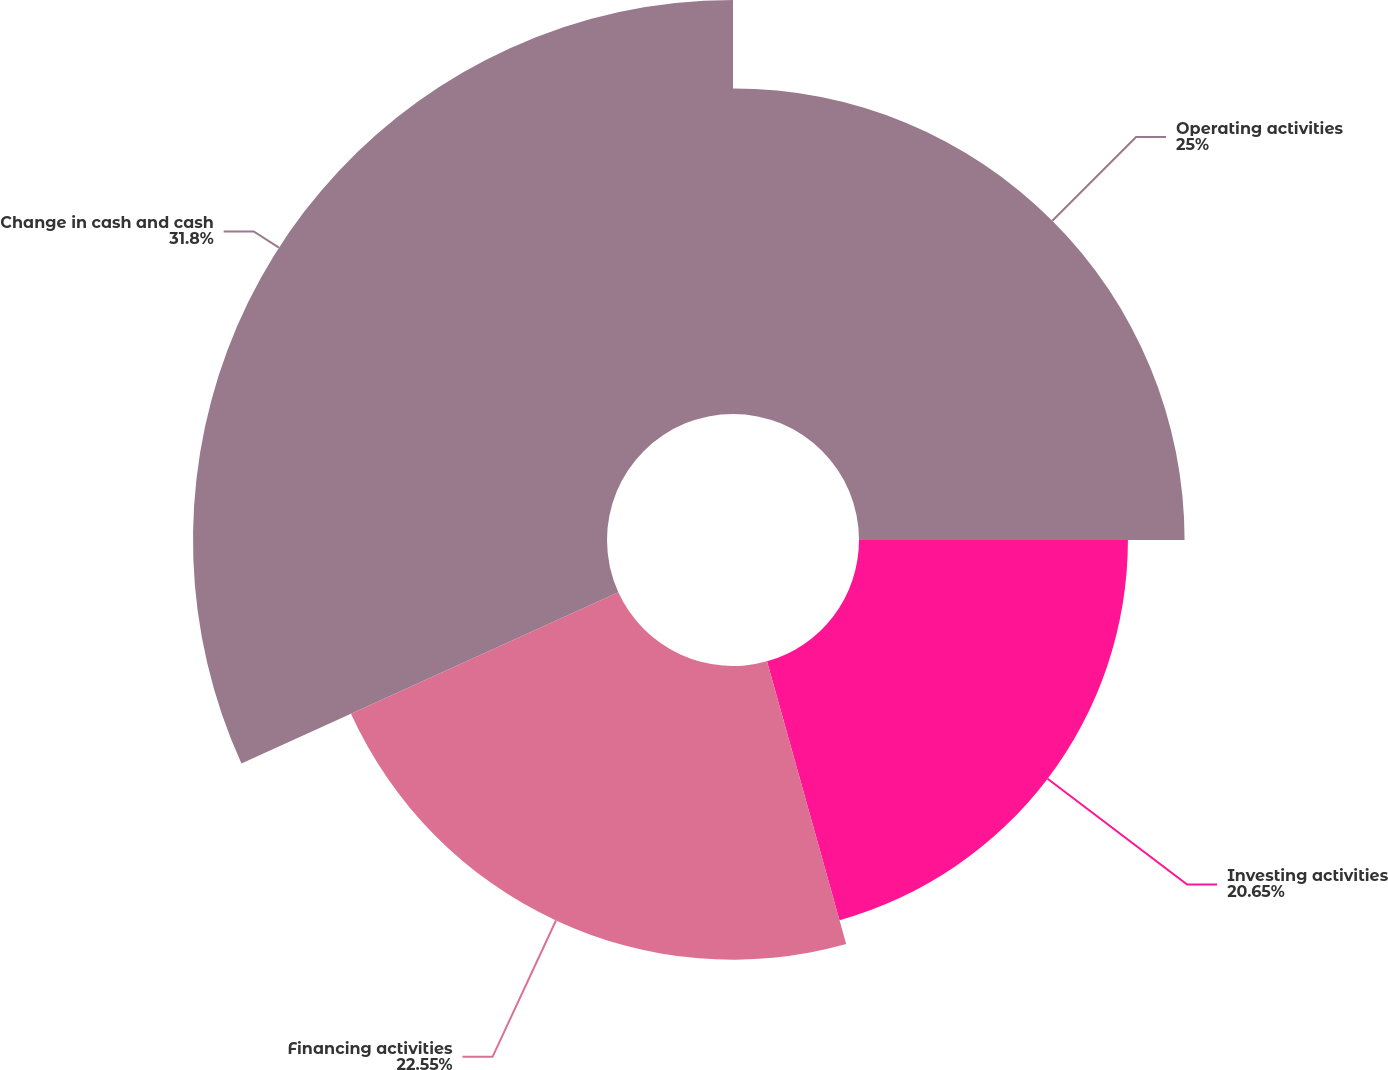<chart> <loc_0><loc_0><loc_500><loc_500><pie_chart><fcel>Operating activities<fcel>Investing activities<fcel>Financing activities<fcel>Change in cash and cash<nl><fcel>25.0%<fcel>20.65%<fcel>22.55%<fcel>31.79%<nl></chart> 